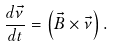Convert formula to latex. <formula><loc_0><loc_0><loc_500><loc_500>\frac { d \vec { \nu } } { d t } = \left ( \vec { B } \times \vec { \nu } \right ) .</formula> 